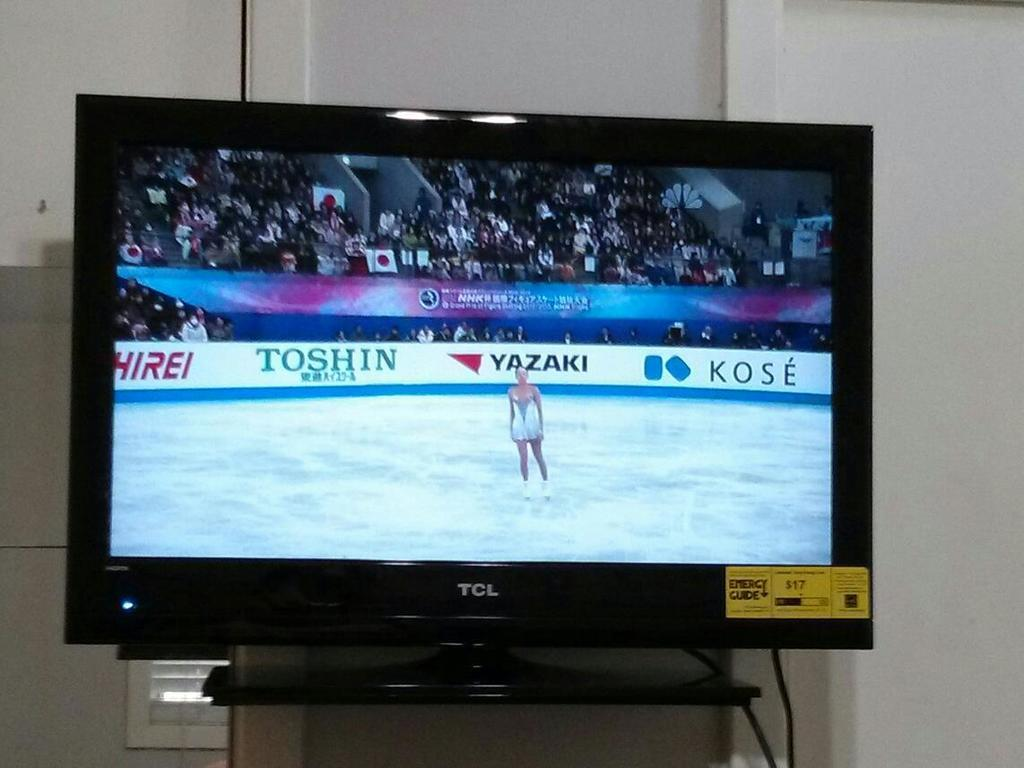<image>
Render a clear and concise summary of the photo. TOSHIN is being advertise on the wall behind the skater. 